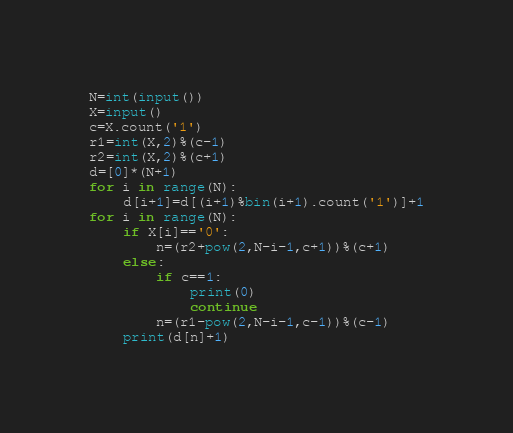<code> <loc_0><loc_0><loc_500><loc_500><_Python_>N=int(input())
X=input()
c=X.count('1')
r1=int(X,2)%(c-1)
r2=int(X,2)%(c+1)
d=[0]*(N+1)
for i in range(N):
    d[i+1]=d[(i+1)%bin(i+1).count('1')]+1
for i in range(N):
    if X[i]=='0':
        n=(r2+pow(2,N-i-1,c+1))%(c+1)
    else:
        if c==1:
            print(0)
            continue
        n=(r1-pow(2,N-i-1,c-1))%(c-1)
    print(d[n]+1)</code> 